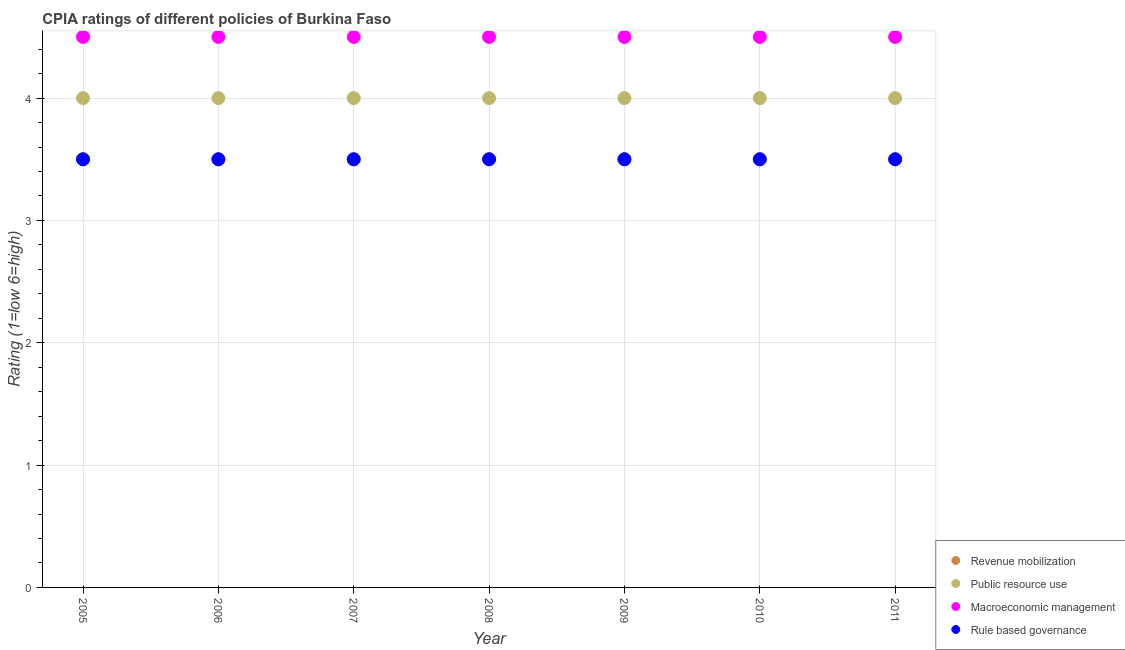Is the number of dotlines equal to the number of legend labels?
Your answer should be very brief. Yes. Across all years, what is the minimum cpia rating of macroeconomic management?
Make the answer very short. 4.5. In which year was the cpia rating of revenue mobilization maximum?
Offer a very short reply. 2005. What is the total cpia rating of macroeconomic management in the graph?
Keep it short and to the point. 31.5. What is the difference between the cpia rating of rule based governance in 2006 and that in 2007?
Your response must be concise. 0. What is the average cpia rating of revenue mobilization per year?
Ensure brevity in your answer.  3.5. In the year 2005, what is the difference between the cpia rating of revenue mobilization and cpia rating of macroeconomic management?
Give a very brief answer. -1. What is the ratio of the cpia rating of public resource use in 2006 to that in 2009?
Offer a very short reply. 1. Is the cpia rating of rule based governance in 2006 less than that in 2008?
Your answer should be compact. No. What is the difference between the highest and the second highest cpia rating of rule based governance?
Your response must be concise. 0. In how many years, is the cpia rating of revenue mobilization greater than the average cpia rating of revenue mobilization taken over all years?
Keep it short and to the point. 0. Is the sum of the cpia rating of revenue mobilization in 2009 and 2011 greater than the maximum cpia rating of public resource use across all years?
Give a very brief answer. Yes. Is it the case that in every year, the sum of the cpia rating of public resource use and cpia rating of revenue mobilization is greater than the sum of cpia rating of macroeconomic management and cpia rating of rule based governance?
Make the answer very short. No. Does the cpia rating of macroeconomic management monotonically increase over the years?
Your answer should be compact. No. Is the cpia rating of rule based governance strictly greater than the cpia rating of macroeconomic management over the years?
Provide a succinct answer. No. Is the cpia rating of macroeconomic management strictly less than the cpia rating of rule based governance over the years?
Provide a succinct answer. No. How many years are there in the graph?
Your answer should be compact. 7. What is the difference between two consecutive major ticks on the Y-axis?
Provide a short and direct response. 1. Are the values on the major ticks of Y-axis written in scientific E-notation?
Provide a succinct answer. No. Does the graph contain grids?
Ensure brevity in your answer.  Yes. What is the title of the graph?
Provide a short and direct response. CPIA ratings of different policies of Burkina Faso. What is the Rating (1=low 6=high) in Revenue mobilization in 2005?
Offer a very short reply. 3.5. What is the Rating (1=low 6=high) of Public resource use in 2005?
Provide a succinct answer. 4. What is the Rating (1=low 6=high) in Revenue mobilization in 2006?
Provide a short and direct response. 3.5. What is the Rating (1=low 6=high) of Public resource use in 2006?
Offer a very short reply. 4. What is the Rating (1=low 6=high) of Revenue mobilization in 2007?
Keep it short and to the point. 3.5. What is the Rating (1=low 6=high) of Macroeconomic management in 2007?
Offer a terse response. 4.5. What is the Rating (1=low 6=high) in Revenue mobilization in 2008?
Ensure brevity in your answer.  3.5. What is the Rating (1=low 6=high) of Rule based governance in 2008?
Your response must be concise. 3.5. What is the Rating (1=low 6=high) in Public resource use in 2009?
Give a very brief answer. 4. What is the Rating (1=low 6=high) in Public resource use in 2010?
Provide a short and direct response. 4. What is the Rating (1=low 6=high) of Macroeconomic management in 2010?
Your answer should be very brief. 4.5. What is the Rating (1=low 6=high) in Rule based governance in 2010?
Ensure brevity in your answer.  3.5. What is the Rating (1=low 6=high) in Public resource use in 2011?
Keep it short and to the point. 4. Across all years, what is the maximum Rating (1=low 6=high) in Public resource use?
Provide a succinct answer. 4. Across all years, what is the maximum Rating (1=low 6=high) in Macroeconomic management?
Your answer should be very brief. 4.5. Across all years, what is the minimum Rating (1=low 6=high) in Revenue mobilization?
Offer a terse response. 3.5. Across all years, what is the minimum Rating (1=low 6=high) in Public resource use?
Offer a terse response. 4. Across all years, what is the minimum Rating (1=low 6=high) in Macroeconomic management?
Provide a short and direct response. 4.5. Across all years, what is the minimum Rating (1=low 6=high) of Rule based governance?
Make the answer very short. 3.5. What is the total Rating (1=low 6=high) in Macroeconomic management in the graph?
Provide a succinct answer. 31.5. What is the total Rating (1=low 6=high) of Rule based governance in the graph?
Make the answer very short. 24.5. What is the difference between the Rating (1=low 6=high) of Public resource use in 2005 and that in 2006?
Your response must be concise. 0. What is the difference between the Rating (1=low 6=high) in Rule based governance in 2005 and that in 2006?
Keep it short and to the point. 0. What is the difference between the Rating (1=low 6=high) of Public resource use in 2005 and that in 2007?
Give a very brief answer. 0. What is the difference between the Rating (1=low 6=high) of Macroeconomic management in 2005 and that in 2007?
Give a very brief answer. 0. What is the difference between the Rating (1=low 6=high) in Rule based governance in 2005 and that in 2007?
Offer a terse response. 0. What is the difference between the Rating (1=low 6=high) of Revenue mobilization in 2005 and that in 2008?
Keep it short and to the point. 0. What is the difference between the Rating (1=low 6=high) of Revenue mobilization in 2005 and that in 2009?
Your answer should be compact. 0. What is the difference between the Rating (1=low 6=high) of Rule based governance in 2005 and that in 2009?
Ensure brevity in your answer.  0. What is the difference between the Rating (1=low 6=high) in Revenue mobilization in 2005 and that in 2011?
Provide a short and direct response. 0. What is the difference between the Rating (1=low 6=high) in Rule based governance in 2006 and that in 2007?
Your answer should be very brief. 0. What is the difference between the Rating (1=low 6=high) in Macroeconomic management in 2006 and that in 2008?
Keep it short and to the point. 0. What is the difference between the Rating (1=low 6=high) of Rule based governance in 2006 and that in 2008?
Make the answer very short. 0. What is the difference between the Rating (1=low 6=high) of Revenue mobilization in 2006 and that in 2009?
Your response must be concise. 0. What is the difference between the Rating (1=low 6=high) of Rule based governance in 2006 and that in 2009?
Offer a very short reply. 0. What is the difference between the Rating (1=low 6=high) in Revenue mobilization in 2006 and that in 2010?
Offer a terse response. 0. What is the difference between the Rating (1=low 6=high) of Macroeconomic management in 2006 and that in 2010?
Make the answer very short. 0. What is the difference between the Rating (1=low 6=high) of Rule based governance in 2006 and that in 2010?
Your answer should be compact. 0. What is the difference between the Rating (1=low 6=high) in Revenue mobilization in 2006 and that in 2011?
Give a very brief answer. 0. What is the difference between the Rating (1=low 6=high) of Public resource use in 2006 and that in 2011?
Provide a succinct answer. 0. What is the difference between the Rating (1=low 6=high) in Rule based governance in 2006 and that in 2011?
Give a very brief answer. 0. What is the difference between the Rating (1=low 6=high) of Revenue mobilization in 2007 and that in 2008?
Give a very brief answer. 0. What is the difference between the Rating (1=low 6=high) of Public resource use in 2007 and that in 2008?
Offer a very short reply. 0. What is the difference between the Rating (1=low 6=high) of Revenue mobilization in 2007 and that in 2009?
Make the answer very short. 0. What is the difference between the Rating (1=low 6=high) of Rule based governance in 2007 and that in 2009?
Offer a very short reply. 0. What is the difference between the Rating (1=low 6=high) in Revenue mobilization in 2007 and that in 2010?
Keep it short and to the point. 0. What is the difference between the Rating (1=low 6=high) in Public resource use in 2007 and that in 2010?
Your answer should be very brief. 0. What is the difference between the Rating (1=low 6=high) of Public resource use in 2007 and that in 2011?
Your answer should be very brief. 0. What is the difference between the Rating (1=low 6=high) of Macroeconomic management in 2007 and that in 2011?
Give a very brief answer. 0. What is the difference between the Rating (1=low 6=high) of Public resource use in 2008 and that in 2009?
Your answer should be compact. 0. What is the difference between the Rating (1=low 6=high) in Rule based governance in 2008 and that in 2009?
Ensure brevity in your answer.  0. What is the difference between the Rating (1=low 6=high) in Public resource use in 2008 and that in 2010?
Keep it short and to the point. 0. What is the difference between the Rating (1=low 6=high) in Macroeconomic management in 2008 and that in 2010?
Provide a short and direct response. 0. What is the difference between the Rating (1=low 6=high) of Public resource use in 2008 and that in 2011?
Provide a succinct answer. 0. What is the difference between the Rating (1=low 6=high) in Rule based governance in 2009 and that in 2010?
Your response must be concise. 0. What is the difference between the Rating (1=low 6=high) of Macroeconomic management in 2009 and that in 2011?
Give a very brief answer. 0. What is the difference between the Rating (1=low 6=high) of Rule based governance in 2009 and that in 2011?
Offer a terse response. 0. What is the difference between the Rating (1=low 6=high) in Macroeconomic management in 2010 and that in 2011?
Offer a terse response. 0. What is the difference between the Rating (1=low 6=high) of Rule based governance in 2010 and that in 2011?
Provide a short and direct response. 0. What is the difference between the Rating (1=low 6=high) of Revenue mobilization in 2005 and the Rating (1=low 6=high) of Macroeconomic management in 2006?
Make the answer very short. -1. What is the difference between the Rating (1=low 6=high) of Revenue mobilization in 2005 and the Rating (1=low 6=high) of Rule based governance in 2006?
Give a very brief answer. 0. What is the difference between the Rating (1=low 6=high) in Public resource use in 2005 and the Rating (1=low 6=high) in Macroeconomic management in 2006?
Keep it short and to the point. -0.5. What is the difference between the Rating (1=low 6=high) in Public resource use in 2005 and the Rating (1=low 6=high) in Rule based governance in 2006?
Keep it short and to the point. 0.5. What is the difference between the Rating (1=low 6=high) in Macroeconomic management in 2005 and the Rating (1=low 6=high) in Rule based governance in 2006?
Offer a very short reply. 1. What is the difference between the Rating (1=low 6=high) in Revenue mobilization in 2005 and the Rating (1=low 6=high) in Macroeconomic management in 2008?
Provide a short and direct response. -1. What is the difference between the Rating (1=low 6=high) of Revenue mobilization in 2005 and the Rating (1=low 6=high) of Rule based governance in 2008?
Keep it short and to the point. 0. What is the difference between the Rating (1=low 6=high) in Macroeconomic management in 2005 and the Rating (1=low 6=high) in Rule based governance in 2008?
Give a very brief answer. 1. What is the difference between the Rating (1=low 6=high) of Revenue mobilization in 2005 and the Rating (1=low 6=high) of Public resource use in 2009?
Make the answer very short. -0.5. What is the difference between the Rating (1=low 6=high) of Revenue mobilization in 2005 and the Rating (1=low 6=high) of Rule based governance in 2009?
Keep it short and to the point. 0. What is the difference between the Rating (1=low 6=high) in Macroeconomic management in 2005 and the Rating (1=low 6=high) in Rule based governance in 2009?
Give a very brief answer. 1. What is the difference between the Rating (1=low 6=high) of Public resource use in 2005 and the Rating (1=low 6=high) of Macroeconomic management in 2010?
Your response must be concise. -0.5. What is the difference between the Rating (1=low 6=high) in Public resource use in 2005 and the Rating (1=low 6=high) in Rule based governance in 2010?
Offer a terse response. 0.5. What is the difference between the Rating (1=low 6=high) in Macroeconomic management in 2005 and the Rating (1=low 6=high) in Rule based governance in 2010?
Your response must be concise. 1. What is the difference between the Rating (1=low 6=high) of Revenue mobilization in 2005 and the Rating (1=low 6=high) of Macroeconomic management in 2011?
Keep it short and to the point. -1. What is the difference between the Rating (1=low 6=high) in Revenue mobilization in 2005 and the Rating (1=low 6=high) in Rule based governance in 2011?
Keep it short and to the point. 0. What is the difference between the Rating (1=low 6=high) in Public resource use in 2005 and the Rating (1=low 6=high) in Macroeconomic management in 2011?
Offer a terse response. -0.5. What is the difference between the Rating (1=low 6=high) of Public resource use in 2006 and the Rating (1=low 6=high) of Macroeconomic management in 2007?
Offer a very short reply. -0.5. What is the difference between the Rating (1=low 6=high) in Revenue mobilization in 2006 and the Rating (1=low 6=high) in Public resource use in 2008?
Provide a short and direct response. -0.5. What is the difference between the Rating (1=low 6=high) in Revenue mobilization in 2006 and the Rating (1=low 6=high) in Macroeconomic management in 2008?
Your answer should be very brief. -1. What is the difference between the Rating (1=low 6=high) in Revenue mobilization in 2006 and the Rating (1=low 6=high) in Rule based governance in 2008?
Your answer should be compact. 0. What is the difference between the Rating (1=low 6=high) in Public resource use in 2006 and the Rating (1=low 6=high) in Rule based governance in 2008?
Offer a terse response. 0.5. What is the difference between the Rating (1=low 6=high) of Public resource use in 2006 and the Rating (1=low 6=high) of Macroeconomic management in 2009?
Provide a succinct answer. -0.5. What is the difference between the Rating (1=low 6=high) of Public resource use in 2006 and the Rating (1=low 6=high) of Rule based governance in 2009?
Ensure brevity in your answer.  0.5. What is the difference between the Rating (1=low 6=high) in Macroeconomic management in 2006 and the Rating (1=low 6=high) in Rule based governance in 2009?
Provide a short and direct response. 1. What is the difference between the Rating (1=low 6=high) in Revenue mobilization in 2006 and the Rating (1=low 6=high) in Rule based governance in 2010?
Make the answer very short. 0. What is the difference between the Rating (1=low 6=high) in Public resource use in 2006 and the Rating (1=low 6=high) in Macroeconomic management in 2010?
Your answer should be compact. -0.5. What is the difference between the Rating (1=low 6=high) of Macroeconomic management in 2006 and the Rating (1=low 6=high) of Rule based governance in 2010?
Make the answer very short. 1. What is the difference between the Rating (1=low 6=high) of Revenue mobilization in 2006 and the Rating (1=low 6=high) of Public resource use in 2011?
Your answer should be very brief. -0.5. What is the difference between the Rating (1=low 6=high) of Revenue mobilization in 2006 and the Rating (1=low 6=high) of Macroeconomic management in 2011?
Provide a short and direct response. -1. What is the difference between the Rating (1=low 6=high) in Revenue mobilization in 2006 and the Rating (1=low 6=high) in Rule based governance in 2011?
Your answer should be very brief. 0. What is the difference between the Rating (1=low 6=high) of Public resource use in 2006 and the Rating (1=low 6=high) of Macroeconomic management in 2011?
Your answer should be very brief. -0.5. What is the difference between the Rating (1=low 6=high) in Public resource use in 2006 and the Rating (1=low 6=high) in Rule based governance in 2011?
Provide a succinct answer. 0.5. What is the difference between the Rating (1=low 6=high) in Macroeconomic management in 2006 and the Rating (1=low 6=high) in Rule based governance in 2011?
Provide a short and direct response. 1. What is the difference between the Rating (1=low 6=high) in Revenue mobilization in 2007 and the Rating (1=low 6=high) in Macroeconomic management in 2008?
Your answer should be compact. -1. What is the difference between the Rating (1=low 6=high) in Public resource use in 2007 and the Rating (1=low 6=high) in Rule based governance in 2008?
Keep it short and to the point. 0.5. What is the difference between the Rating (1=low 6=high) of Macroeconomic management in 2007 and the Rating (1=low 6=high) of Rule based governance in 2008?
Offer a very short reply. 1. What is the difference between the Rating (1=low 6=high) in Revenue mobilization in 2007 and the Rating (1=low 6=high) in Public resource use in 2009?
Keep it short and to the point. -0.5. What is the difference between the Rating (1=low 6=high) in Revenue mobilization in 2007 and the Rating (1=low 6=high) in Macroeconomic management in 2009?
Keep it short and to the point. -1. What is the difference between the Rating (1=low 6=high) in Public resource use in 2007 and the Rating (1=low 6=high) in Macroeconomic management in 2009?
Offer a very short reply. -0.5. What is the difference between the Rating (1=low 6=high) of Revenue mobilization in 2007 and the Rating (1=low 6=high) of Macroeconomic management in 2010?
Provide a succinct answer. -1. What is the difference between the Rating (1=low 6=high) of Public resource use in 2007 and the Rating (1=low 6=high) of Macroeconomic management in 2010?
Give a very brief answer. -0.5. What is the difference between the Rating (1=low 6=high) of Revenue mobilization in 2007 and the Rating (1=low 6=high) of Public resource use in 2011?
Provide a short and direct response. -0.5. What is the difference between the Rating (1=low 6=high) in Revenue mobilization in 2008 and the Rating (1=low 6=high) in Public resource use in 2009?
Your response must be concise. -0.5. What is the difference between the Rating (1=low 6=high) in Revenue mobilization in 2008 and the Rating (1=low 6=high) in Rule based governance in 2009?
Give a very brief answer. 0. What is the difference between the Rating (1=low 6=high) of Public resource use in 2008 and the Rating (1=low 6=high) of Rule based governance in 2009?
Provide a succinct answer. 0.5. What is the difference between the Rating (1=low 6=high) in Macroeconomic management in 2008 and the Rating (1=low 6=high) in Rule based governance in 2009?
Keep it short and to the point. 1. What is the difference between the Rating (1=low 6=high) of Revenue mobilization in 2008 and the Rating (1=low 6=high) of Public resource use in 2010?
Ensure brevity in your answer.  -0.5. What is the difference between the Rating (1=low 6=high) in Revenue mobilization in 2008 and the Rating (1=low 6=high) in Macroeconomic management in 2011?
Provide a succinct answer. -1. What is the difference between the Rating (1=low 6=high) in Revenue mobilization in 2008 and the Rating (1=low 6=high) in Rule based governance in 2011?
Keep it short and to the point. 0. What is the difference between the Rating (1=low 6=high) of Macroeconomic management in 2008 and the Rating (1=low 6=high) of Rule based governance in 2011?
Provide a succinct answer. 1. What is the difference between the Rating (1=low 6=high) of Revenue mobilization in 2009 and the Rating (1=low 6=high) of Public resource use in 2010?
Your answer should be very brief. -0.5. What is the difference between the Rating (1=low 6=high) in Revenue mobilization in 2009 and the Rating (1=low 6=high) in Macroeconomic management in 2010?
Ensure brevity in your answer.  -1. What is the difference between the Rating (1=low 6=high) in Revenue mobilization in 2009 and the Rating (1=low 6=high) in Rule based governance in 2010?
Offer a very short reply. 0. What is the difference between the Rating (1=low 6=high) of Revenue mobilization in 2009 and the Rating (1=low 6=high) of Public resource use in 2011?
Offer a very short reply. -0.5. What is the difference between the Rating (1=low 6=high) in Revenue mobilization in 2009 and the Rating (1=low 6=high) in Rule based governance in 2011?
Make the answer very short. 0. What is the difference between the Rating (1=low 6=high) in Macroeconomic management in 2009 and the Rating (1=low 6=high) in Rule based governance in 2011?
Your answer should be very brief. 1. What is the difference between the Rating (1=low 6=high) in Revenue mobilization in 2010 and the Rating (1=low 6=high) in Rule based governance in 2011?
Offer a terse response. 0. What is the difference between the Rating (1=low 6=high) in Public resource use in 2010 and the Rating (1=low 6=high) in Macroeconomic management in 2011?
Give a very brief answer. -0.5. What is the difference between the Rating (1=low 6=high) in Macroeconomic management in 2010 and the Rating (1=low 6=high) in Rule based governance in 2011?
Provide a short and direct response. 1. What is the average Rating (1=low 6=high) of Revenue mobilization per year?
Give a very brief answer. 3.5. What is the average Rating (1=low 6=high) of Public resource use per year?
Your response must be concise. 4. What is the average Rating (1=low 6=high) in Macroeconomic management per year?
Ensure brevity in your answer.  4.5. In the year 2005, what is the difference between the Rating (1=low 6=high) in Revenue mobilization and Rating (1=low 6=high) in Macroeconomic management?
Your answer should be very brief. -1. In the year 2005, what is the difference between the Rating (1=low 6=high) of Revenue mobilization and Rating (1=low 6=high) of Rule based governance?
Ensure brevity in your answer.  0. In the year 2005, what is the difference between the Rating (1=low 6=high) in Public resource use and Rating (1=low 6=high) in Macroeconomic management?
Make the answer very short. -0.5. In the year 2006, what is the difference between the Rating (1=low 6=high) in Public resource use and Rating (1=low 6=high) in Macroeconomic management?
Your answer should be very brief. -0.5. In the year 2006, what is the difference between the Rating (1=low 6=high) of Macroeconomic management and Rating (1=low 6=high) of Rule based governance?
Offer a terse response. 1. In the year 2007, what is the difference between the Rating (1=low 6=high) in Revenue mobilization and Rating (1=low 6=high) in Public resource use?
Offer a very short reply. -0.5. In the year 2007, what is the difference between the Rating (1=low 6=high) of Revenue mobilization and Rating (1=low 6=high) of Macroeconomic management?
Offer a very short reply. -1. In the year 2007, what is the difference between the Rating (1=low 6=high) in Revenue mobilization and Rating (1=low 6=high) in Rule based governance?
Offer a terse response. 0. In the year 2007, what is the difference between the Rating (1=low 6=high) in Public resource use and Rating (1=low 6=high) in Macroeconomic management?
Ensure brevity in your answer.  -0.5. In the year 2008, what is the difference between the Rating (1=low 6=high) of Revenue mobilization and Rating (1=low 6=high) of Public resource use?
Give a very brief answer. -0.5. In the year 2008, what is the difference between the Rating (1=low 6=high) of Revenue mobilization and Rating (1=low 6=high) of Macroeconomic management?
Offer a terse response. -1. In the year 2008, what is the difference between the Rating (1=low 6=high) of Revenue mobilization and Rating (1=low 6=high) of Rule based governance?
Your answer should be compact. 0. In the year 2008, what is the difference between the Rating (1=low 6=high) in Public resource use and Rating (1=low 6=high) in Rule based governance?
Provide a short and direct response. 0.5. In the year 2008, what is the difference between the Rating (1=low 6=high) of Macroeconomic management and Rating (1=low 6=high) of Rule based governance?
Give a very brief answer. 1. In the year 2009, what is the difference between the Rating (1=low 6=high) of Revenue mobilization and Rating (1=low 6=high) of Rule based governance?
Your answer should be very brief. 0. In the year 2009, what is the difference between the Rating (1=low 6=high) in Public resource use and Rating (1=low 6=high) in Macroeconomic management?
Make the answer very short. -0.5. In the year 2009, what is the difference between the Rating (1=low 6=high) in Public resource use and Rating (1=low 6=high) in Rule based governance?
Keep it short and to the point. 0.5. In the year 2009, what is the difference between the Rating (1=low 6=high) in Macroeconomic management and Rating (1=low 6=high) in Rule based governance?
Provide a succinct answer. 1. In the year 2010, what is the difference between the Rating (1=low 6=high) in Public resource use and Rating (1=low 6=high) in Macroeconomic management?
Your response must be concise. -0.5. In the year 2010, what is the difference between the Rating (1=low 6=high) in Public resource use and Rating (1=low 6=high) in Rule based governance?
Offer a terse response. 0.5. In the year 2010, what is the difference between the Rating (1=low 6=high) of Macroeconomic management and Rating (1=low 6=high) of Rule based governance?
Offer a terse response. 1. In the year 2011, what is the difference between the Rating (1=low 6=high) in Revenue mobilization and Rating (1=low 6=high) in Public resource use?
Offer a very short reply. -0.5. In the year 2011, what is the difference between the Rating (1=low 6=high) of Public resource use and Rating (1=low 6=high) of Macroeconomic management?
Make the answer very short. -0.5. What is the ratio of the Rating (1=low 6=high) of Revenue mobilization in 2005 to that in 2006?
Make the answer very short. 1. What is the ratio of the Rating (1=low 6=high) in Rule based governance in 2005 to that in 2006?
Your answer should be compact. 1. What is the ratio of the Rating (1=low 6=high) of Revenue mobilization in 2005 to that in 2007?
Provide a succinct answer. 1. What is the ratio of the Rating (1=low 6=high) in Public resource use in 2005 to that in 2007?
Keep it short and to the point. 1. What is the ratio of the Rating (1=low 6=high) of Macroeconomic management in 2005 to that in 2007?
Keep it short and to the point. 1. What is the ratio of the Rating (1=low 6=high) of Rule based governance in 2005 to that in 2007?
Your response must be concise. 1. What is the ratio of the Rating (1=low 6=high) in Revenue mobilization in 2005 to that in 2008?
Make the answer very short. 1. What is the ratio of the Rating (1=low 6=high) of Macroeconomic management in 2005 to that in 2008?
Provide a short and direct response. 1. What is the ratio of the Rating (1=low 6=high) of Revenue mobilization in 2005 to that in 2009?
Provide a succinct answer. 1. What is the ratio of the Rating (1=low 6=high) of Public resource use in 2005 to that in 2009?
Offer a very short reply. 1. What is the ratio of the Rating (1=low 6=high) in Rule based governance in 2005 to that in 2009?
Provide a succinct answer. 1. What is the ratio of the Rating (1=low 6=high) in Revenue mobilization in 2005 to that in 2010?
Offer a very short reply. 1. What is the ratio of the Rating (1=low 6=high) of Rule based governance in 2005 to that in 2010?
Your answer should be very brief. 1. What is the ratio of the Rating (1=low 6=high) in Revenue mobilization in 2005 to that in 2011?
Provide a succinct answer. 1. What is the ratio of the Rating (1=low 6=high) in Macroeconomic management in 2005 to that in 2011?
Your answer should be very brief. 1. What is the ratio of the Rating (1=low 6=high) in Revenue mobilization in 2006 to that in 2007?
Keep it short and to the point. 1. What is the ratio of the Rating (1=low 6=high) of Rule based governance in 2006 to that in 2008?
Provide a short and direct response. 1. What is the ratio of the Rating (1=low 6=high) in Public resource use in 2006 to that in 2009?
Make the answer very short. 1. What is the ratio of the Rating (1=low 6=high) of Macroeconomic management in 2006 to that in 2009?
Give a very brief answer. 1. What is the ratio of the Rating (1=low 6=high) in Macroeconomic management in 2006 to that in 2010?
Ensure brevity in your answer.  1. What is the ratio of the Rating (1=low 6=high) of Rule based governance in 2006 to that in 2010?
Make the answer very short. 1. What is the ratio of the Rating (1=low 6=high) of Macroeconomic management in 2006 to that in 2011?
Give a very brief answer. 1. What is the ratio of the Rating (1=low 6=high) in Public resource use in 2007 to that in 2008?
Keep it short and to the point. 1. What is the ratio of the Rating (1=low 6=high) of Rule based governance in 2007 to that in 2008?
Offer a very short reply. 1. What is the ratio of the Rating (1=low 6=high) in Public resource use in 2007 to that in 2009?
Provide a succinct answer. 1. What is the ratio of the Rating (1=low 6=high) in Macroeconomic management in 2007 to that in 2009?
Keep it short and to the point. 1. What is the ratio of the Rating (1=low 6=high) of Revenue mobilization in 2007 to that in 2010?
Your answer should be compact. 1. What is the ratio of the Rating (1=low 6=high) of Public resource use in 2007 to that in 2010?
Ensure brevity in your answer.  1. What is the ratio of the Rating (1=low 6=high) in Public resource use in 2007 to that in 2011?
Offer a terse response. 1. What is the ratio of the Rating (1=low 6=high) in Macroeconomic management in 2007 to that in 2011?
Offer a very short reply. 1. What is the ratio of the Rating (1=low 6=high) of Public resource use in 2008 to that in 2010?
Offer a terse response. 1. What is the ratio of the Rating (1=low 6=high) in Macroeconomic management in 2008 to that in 2010?
Your response must be concise. 1. What is the ratio of the Rating (1=low 6=high) of Public resource use in 2008 to that in 2011?
Your answer should be very brief. 1. What is the ratio of the Rating (1=low 6=high) of Rule based governance in 2008 to that in 2011?
Provide a succinct answer. 1. What is the ratio of the Rating (1=low 6=high) of Public resource use in 2009 to that in 2010?
Provide a short and direct response. 1. What is the ratio of the Rating (1=low 6=high) of Macroeconomic management in 2009 to that in 2010?
Your answer should be very brief. 1. What is the ratio of the Rating (1=low 6=high) in Revenue mobilization in 2009 to that in 2011?
Provide a short and direct response. 1. What is the ratio of the Rating (1=low 6=high) in Public resource use in 2010 to that in 2011?
Keep it short and to the point. 1. What is the ratio of the Rating (1=low 6=high) in Rule based governance in 2010 to that in 2011?
Your response must be concise. 1. What is the difference between the highest and the second highest Rating (1=low 6=high) of Public resource use?
Give a very brief answer. 0. What is the difference between the highest and the second highest Rating (1=low 6=high) in Macroeconomic management?
Offer a very short reply. 0. What is the difference between the highest and the lowest Rating (1=low 6=high) of Revenue mobilization?
Make the answer very short. 0. What is the difference between the highest and the lowest Rating (1=low 6=high) in Rule based governance?
Keep it short and to the point. 0. 